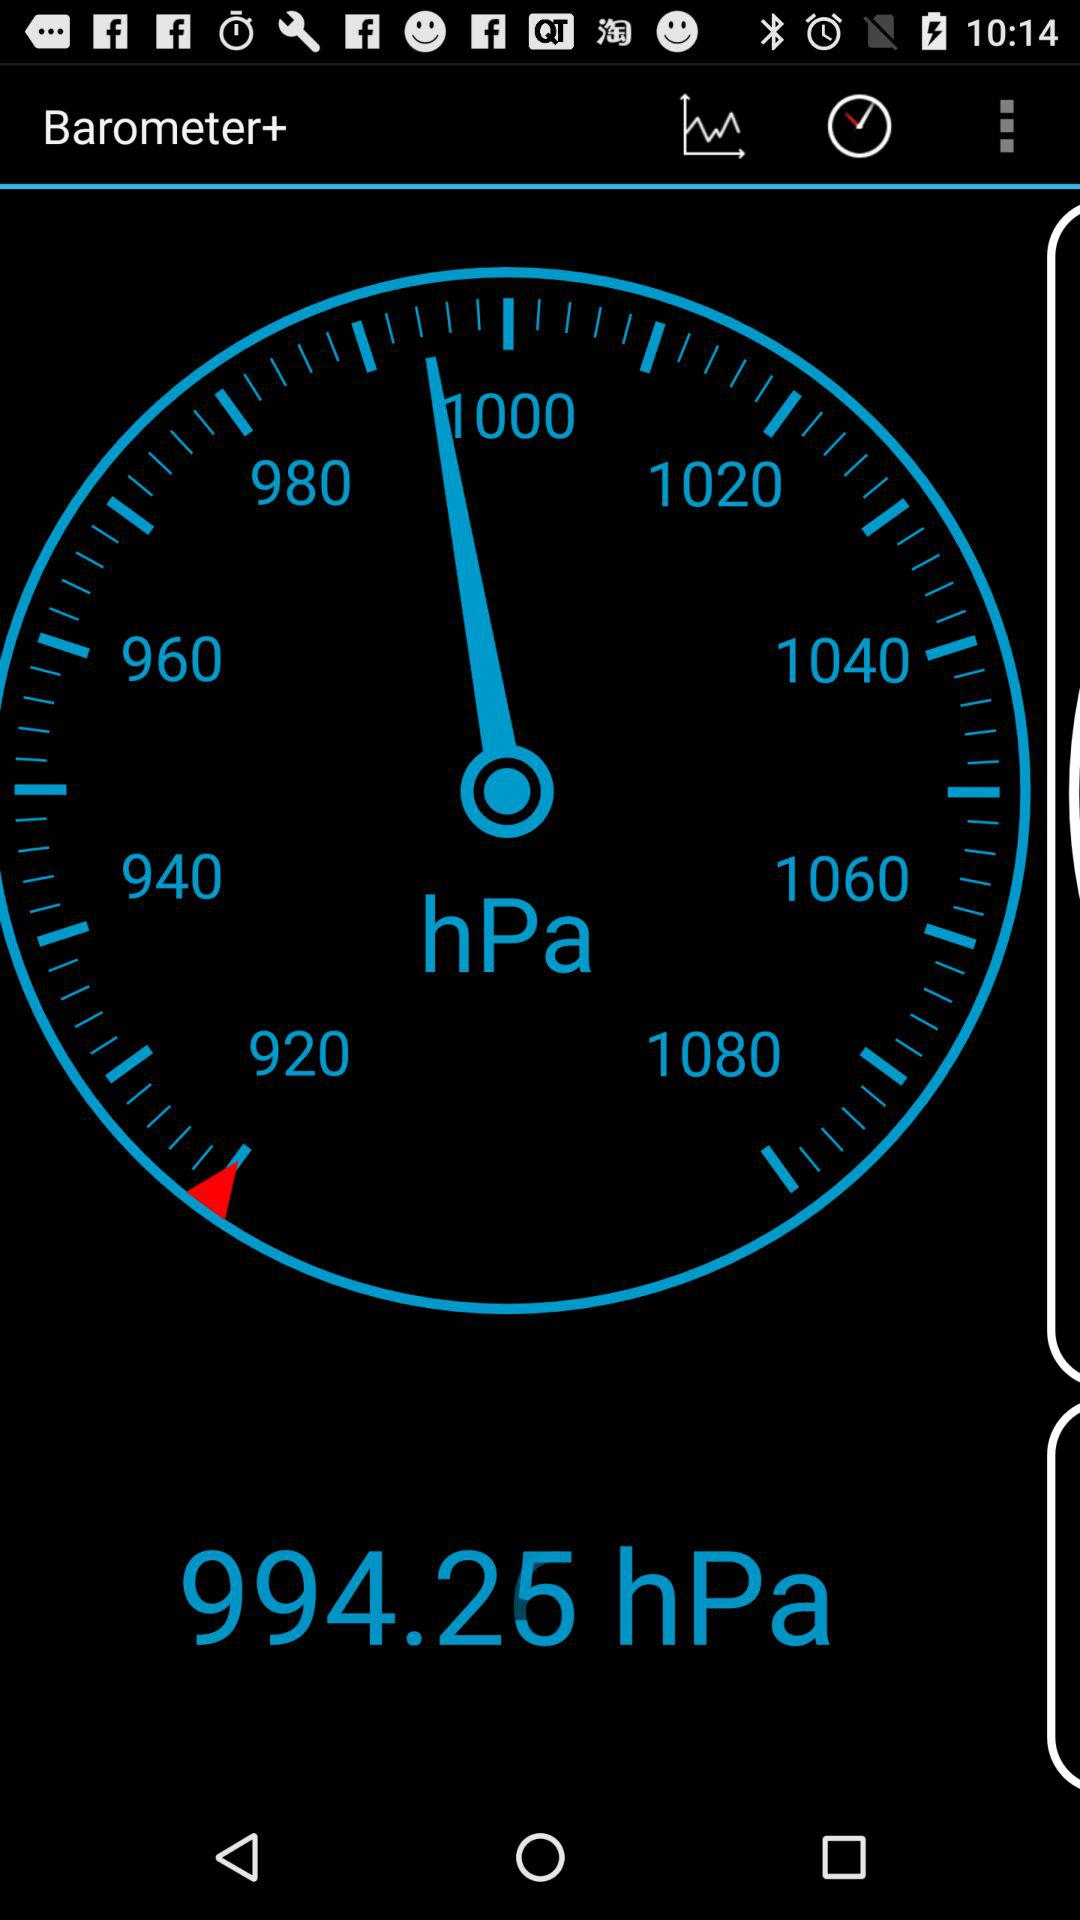What is the current reading on the barometer? The current reading on the barometer is 994.25 hectopascals. 